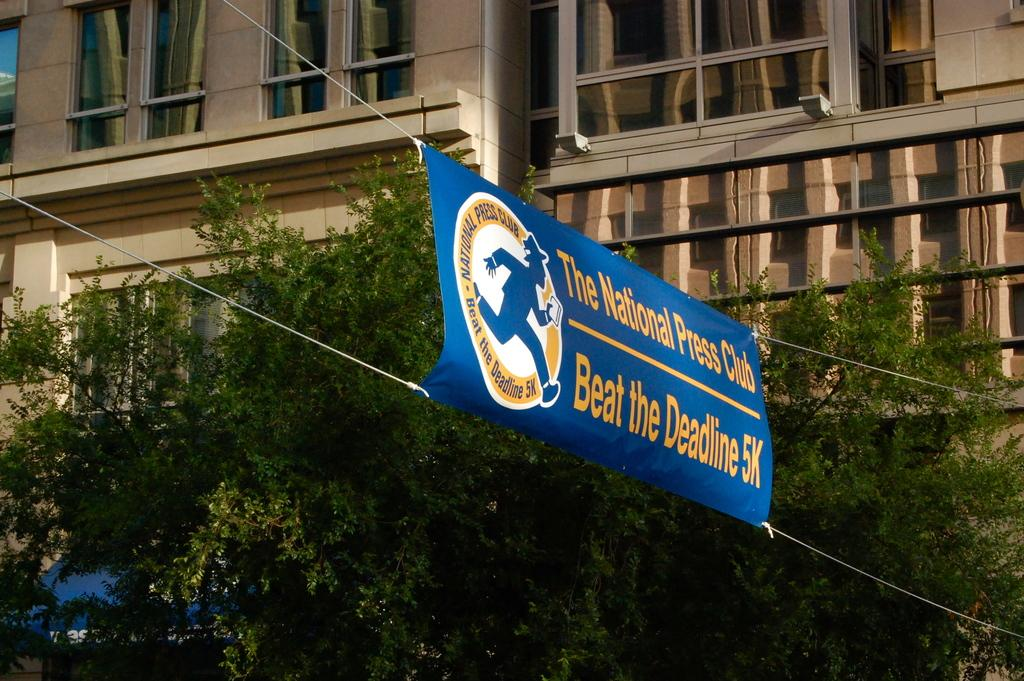What is hanging in the image? There is a banner in the image. How is the banner secured? The banner is tied with ropes. What can be seen in the background of the image? There are trees in the background of the image. What type of building is visible behind the trees? There is a building with glass windows behind the trees. What type of grass is growing on the dock in the image? There is no dock or grass present in the image. 